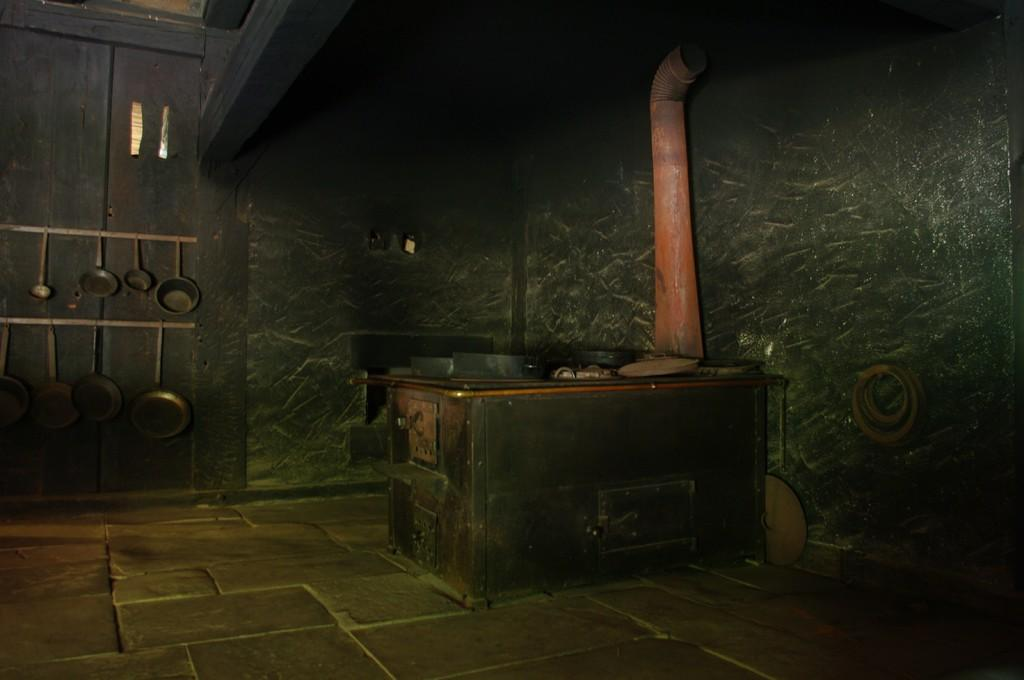What type of space is shown in the image? The image provides an inside view of a room. What can be seen on the left side of the room? There are vessels on the left side of the image. What is located in the center of the room? There is a table in the center of the image. What object is placed on the table? A pipe is present on the table. What type of locket is hanging from the pipe in the image? There is no locket present in the image, and the pipe is not hanging from anything. 